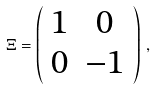<formula> <loc_0><loc_0><loc_500><loc_500>\Xi = \left ( \begin{array} { c c } 1 & 0 \\ 0 & - 1 \end{array} \right ) \, ,</formula> 